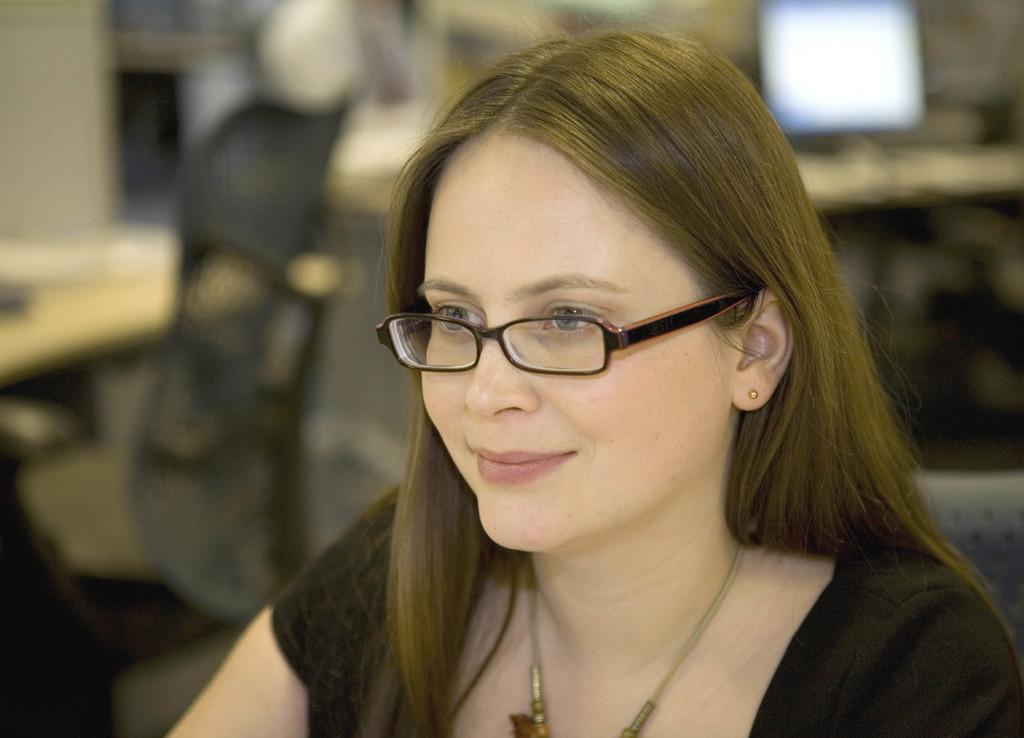Who is the main subject in the foreground of the image? There is a lady in the foreground of the image. What can be observed about the background of the image? The background of the image is blurred. What electronic device is present in the image? There is a monitor screen in the image. What type of furniture is visible in the image? There is a chair in the image. Can you see any jellyfish swimming in the image? There are no jellyfish present in the image. What type of stone is being used as a paperweight on the monitor screen? There is no stone being used as a paperweight on the monitor screen in the image. 